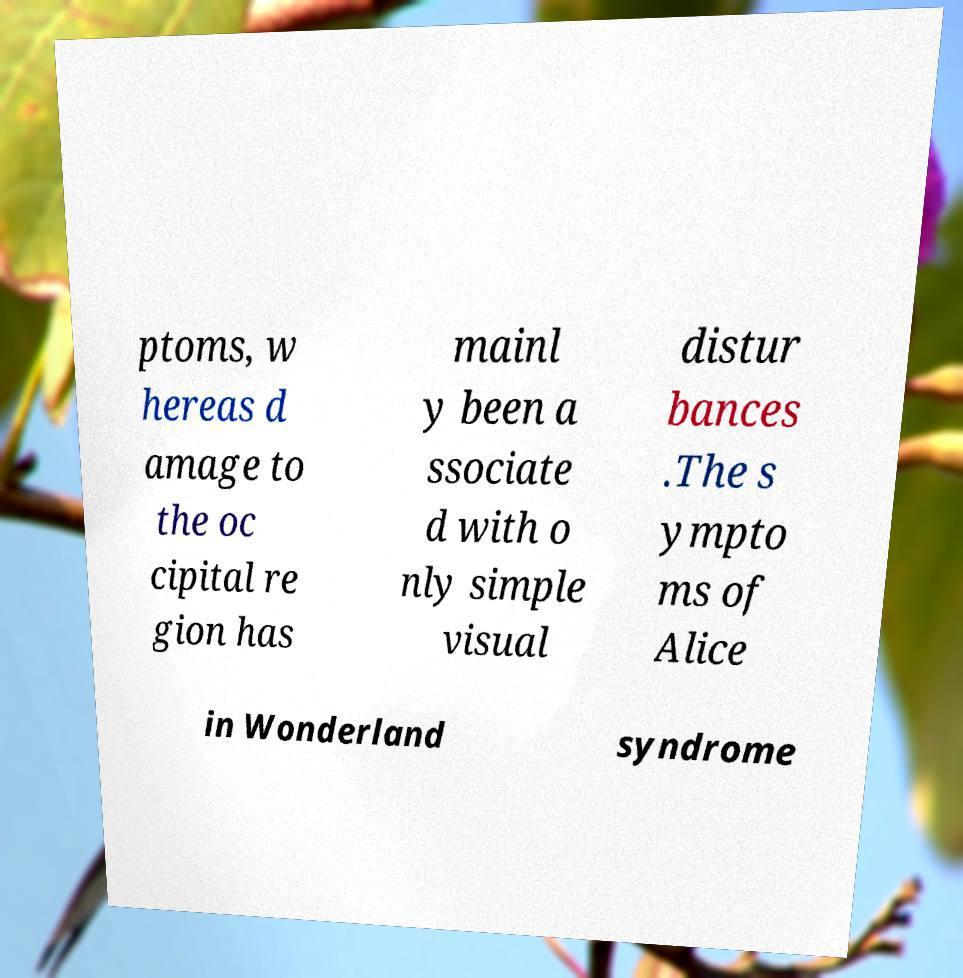What messages or text are displayed in this image? I need them in a readable, typed format. ptoms, w hereas d amage to the oc cipital re gion has mainl y been a ssociate d with o nly simple visual distur bances .The s ympto ms of Alice in Wonderland syndrome 